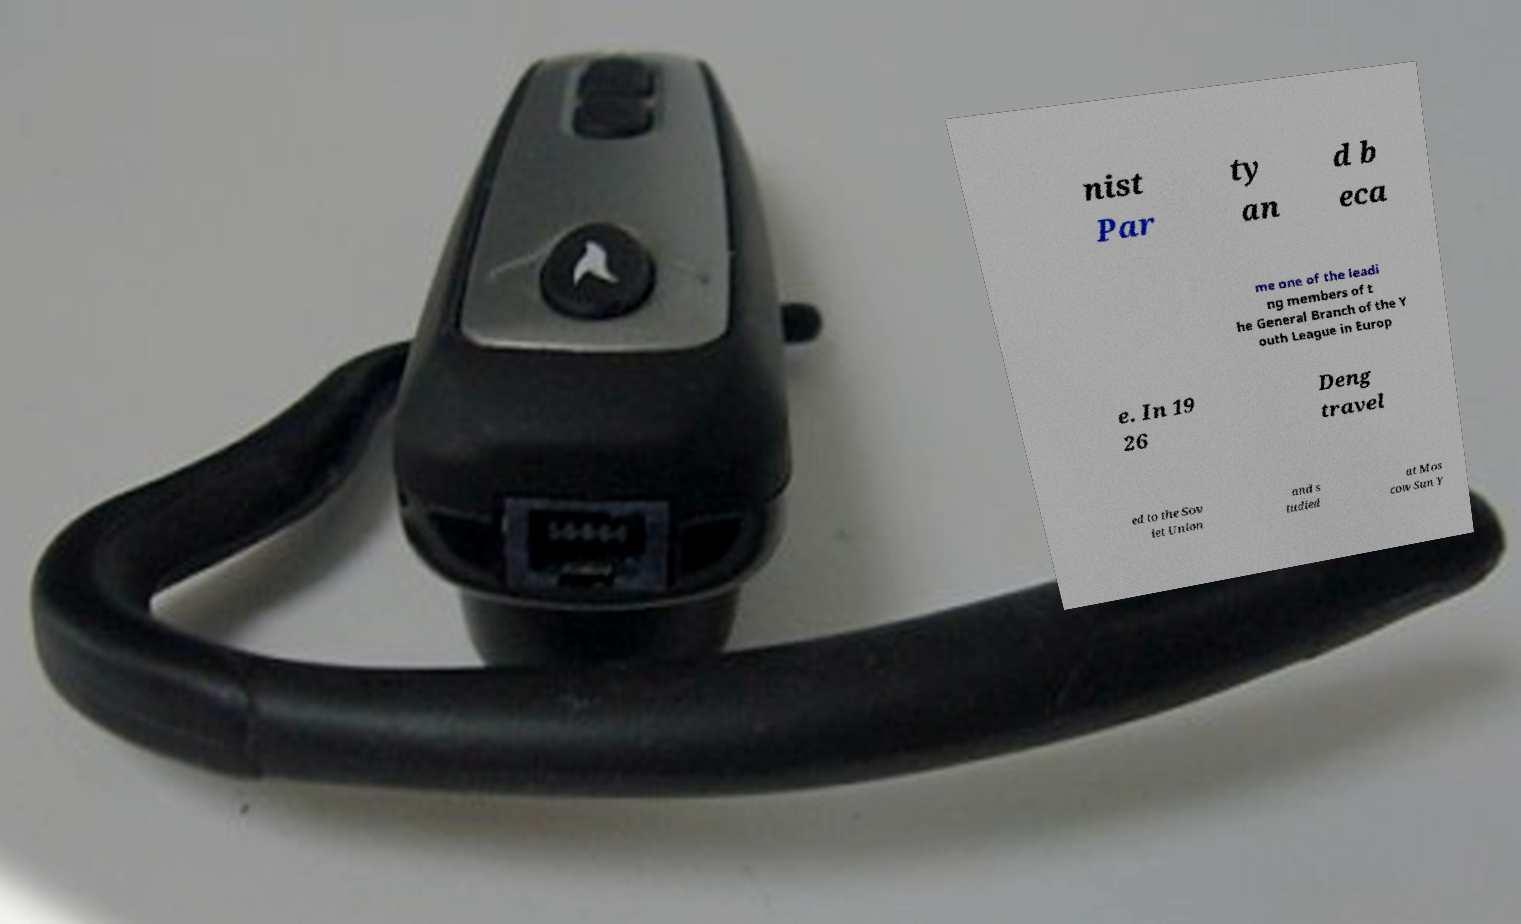Can you read and provide the text displayed in the image?This photo seems to have some interesting text. Can you extract and type it out for me? nist Par ty an d b eca me one of the leadi ng members of t he General Branch of the Y outh League in Europ e. In 19 26 Deng travel ed to the Sov iet Union and s tudied at Mos cow Sun Y 